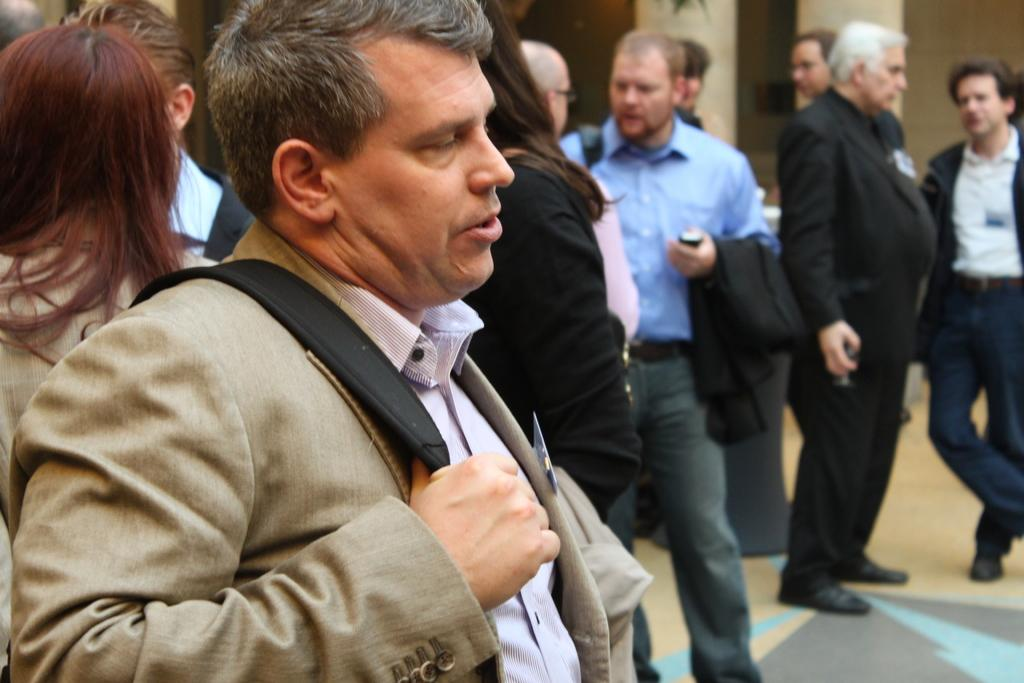Who is the main subject in the image? There is a man in the image. What is the man holding in the image? The man is holding a bag. Can you describe the surrounding environment in the image? There are many other people in the background of the image. What type of smoke can be seen coming from the man's bag in the image? There is no smoke coming from the man's bag in the image. 